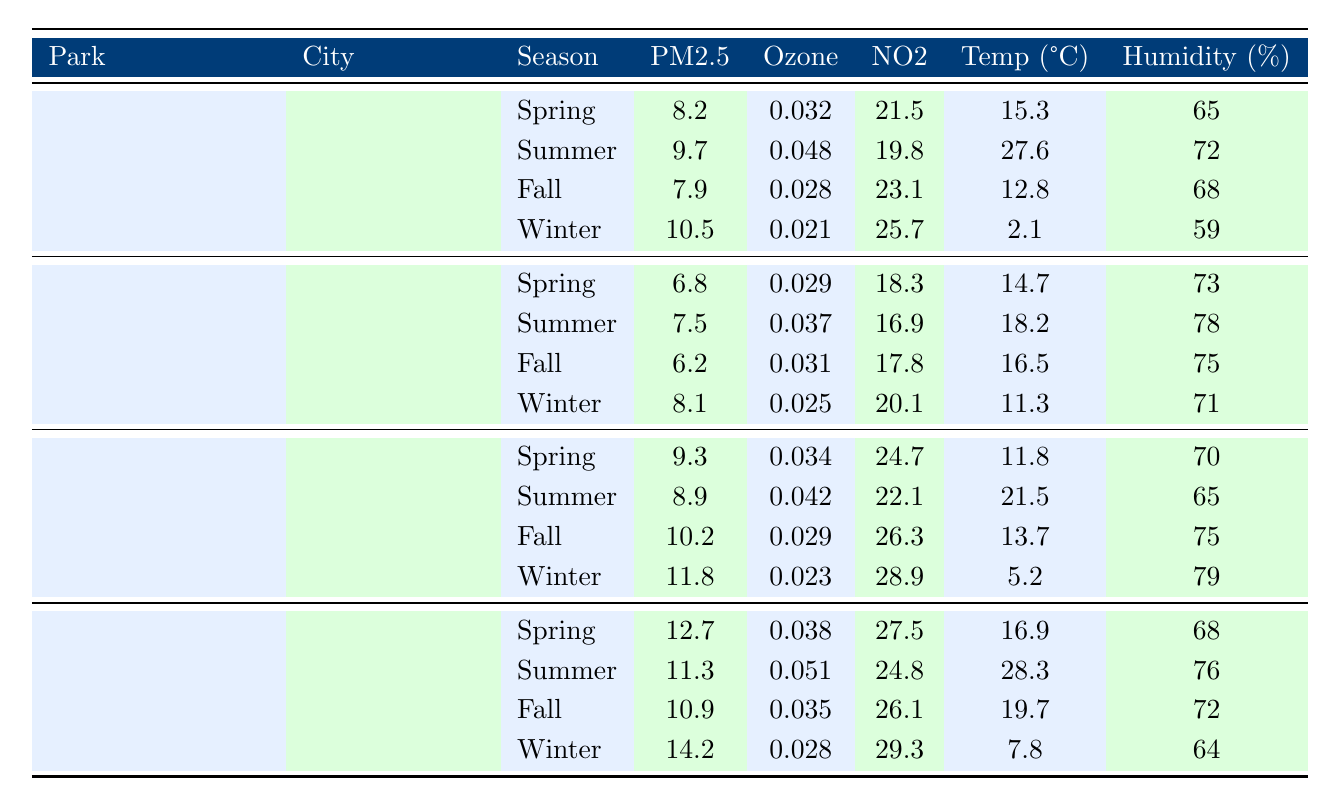What are the PM2.5 levels in Central Park during Winter? From the table, we can see that for Central Park in Winter, the PM2.5 level is listed as 10.5.
Answer: 10.5 What is the highest NO2 level recorded at Golden Gate Park? We look at the NO2 column for Golden Gate Park, and the highest value is in Winter, which is 20.1.
Answer: 20.1 Which season in Hyde Park has the lowest Ozone level? By inspecting the Ozone values for each season in Hyde Park, the Winter season has the lowest Ozone level of 0.023.
Answer: Winter What is the average PM2.5 level for Ueno Park across all seasons? The PM2.5 levels for Ueno Park are 12.7, 11.3, 10.9, and 14.2. Adding these values gives 12.7 + 11.3 + 10.9 + 14.2 = 49.1. To find the average, divide this sum by 4 (the number of seasons): 49.1 / 4 = 12.275.
Answer: 12.275 Is the PM2.5 level in Summer higher in Central Park than in Golden Gate Park? Central Park has a PM2.5 level of 9.7 in Summer, while Golden Gate Park has a level of 7.5. Since 9.7 is greater than 7.5, this statement is true.
Answer: Yes What is the change in Temperature from Spring to Winter in Ueno Park? In Ueno Park, the temperature in Spring is 16.9°C and in Winter it is 7.8°C. The change can be calculated as 16.9 - 7.8 = 9.1°C.
Answer: 9.1°C Which park in Spring has the highest humidity, and what is that humidity value? Checking the Humidity column for Spring across all parks, Central Park has 65%, Golden Gate Park has 73%, Hyde Park has 70%, and Ueno Park has 68%. The highest humidity is 73% in Golden Gate Park.
Answer: Golden Gate Park; 73% Are there any seasons in which the PM2.5 levels for Hyde Park and Ueno Park are exactly the same? Comparing the PM2.5 levels for all seasons, Hyde Park has levels of 9.3, 8.9, 10.2, and 11.8, while Ueno Park has levels of 12.7, 11.3, 10.9, and 14.2. None of these values match.
Answer: No What season has the highest recorded NO2 level across all parks? By looking at all NO2 levels, we note that the highest value is 29.3 in Winter at Ueno Park.
Answer: Winter; 29.3 Which city has the lowest average PM2.5 levels across all parks? The average PM2.5 for each park needs to be calculated: Central Park: (8.2 + 9.7 + 7.9 + 10.5) / 4 = 9.3, Golden Gate Park: (6.8 + 7.5 + 6.2 + 8.1) / 4 = 7.9, Hyde Park: (9.3 + 8.9 + 10.2 + 11.8) / 4 = 10.05, Ueno Park: (12.7 + 11.3 + 10.9 + 14.2) / 4 = 12.275. The lowest average PM2.5 is in Golden Gate Park with a value of 7.9.
Answer: San Francisco; 7.9 